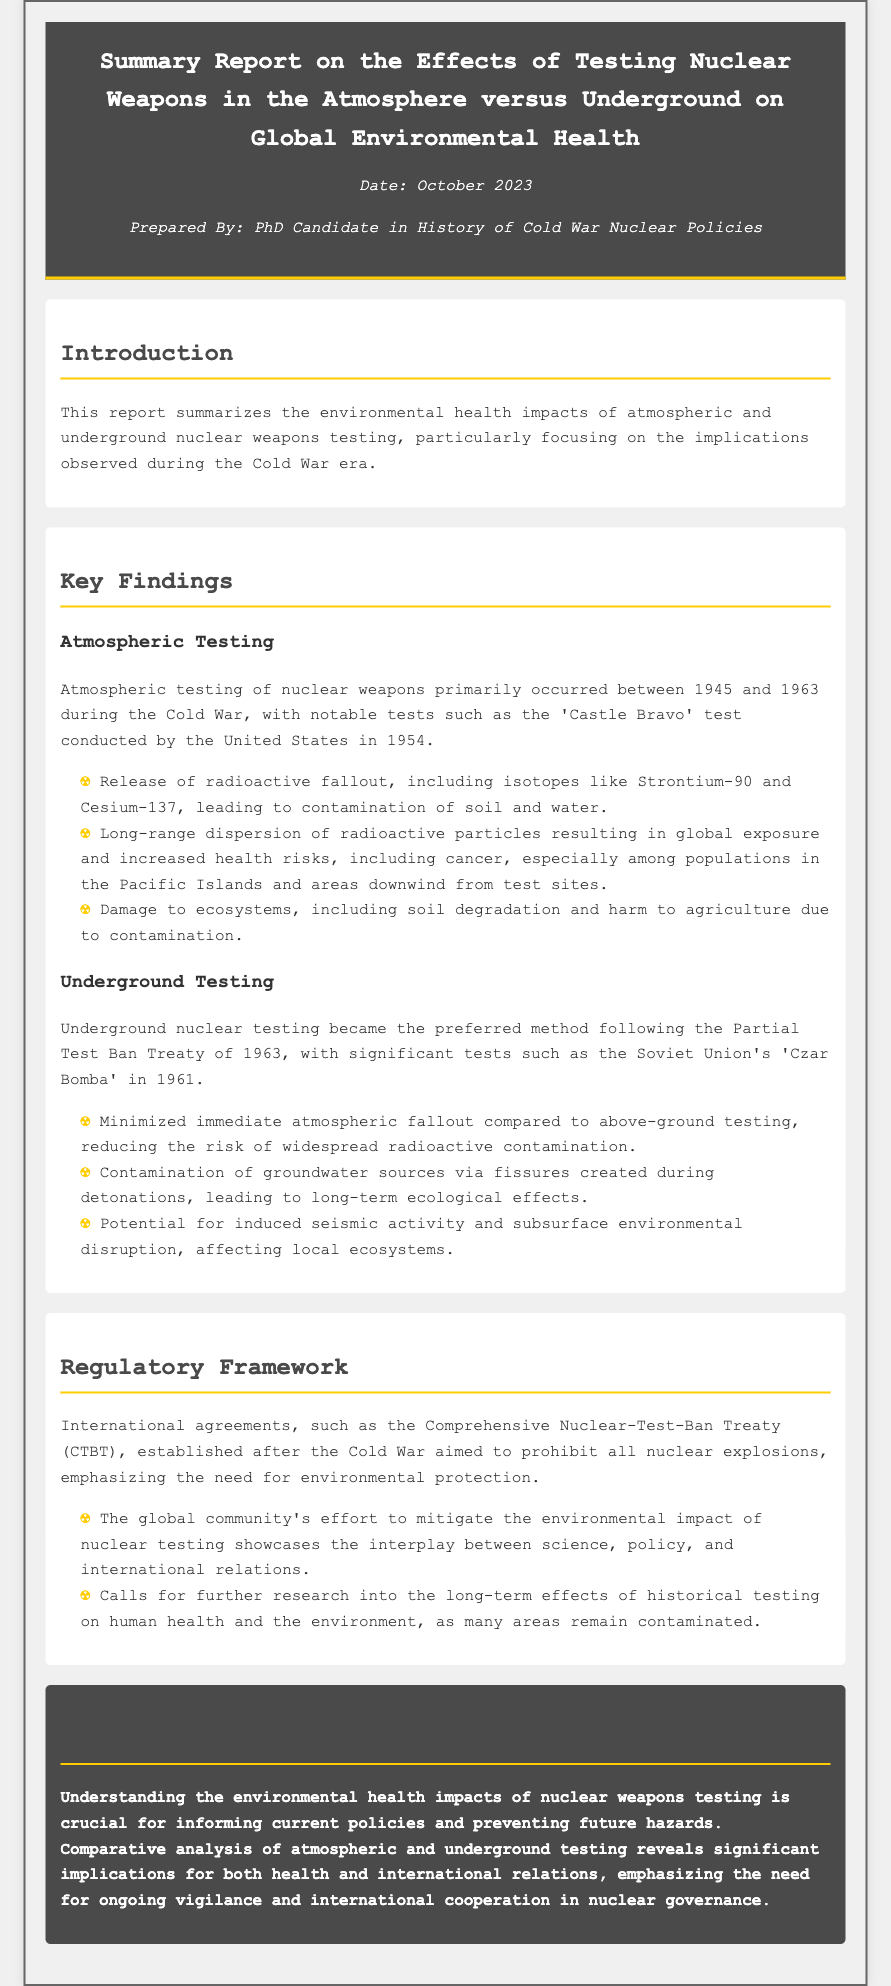What is the date of the report? The date of the report is mentioned in the meta section as October 2023.
Answer: October 2023 Who prepared the report? The report is prepared by a PhD candidate in the History of Cold War Nuclear Policies, as stated in the meta section.
Answer: PhD Candidate in History of Cold War Nuclear Policies What was a significant atmospheric test mentioned? The significant atmospheric test mentioned is the 'Castle Bravo' test conducted by the United States in 1954.
Answer: Castle Bravo What isotopes were released due to atmospheric testing? The isotopes released due to atmospheric testing include Strontium-90 and Cesium-137, as listed in the findings section.
Answer: Strontium-90 and Cesium-137 What is one long-term effect of underground testing? One long-term effect of underground testing is the contamination of groundwater sources via fissures created during detonations.
Answer: Contamination of groundwater sources What treaty aimed to prohibit all nuclear explosions? The treaty that aimed to prohibit all nuclear explosions is the Comprehensive Nuclear-Test-Ban Treaty (CTBT) as stated in the regulatory framework section.
Answer: Comprehensive Nuclear-Test-Ban Treaty (CTBT) What does the report emphasize about international relations? The report emphasizes the need for ongoing vigilance and international cooperation in nuclear governance as reflected in the conclusion.
Answer: Ongoing vigilance and international cooperation What was the primary focus of the report? The primary focus of the report is on the environmental health impacts of atmospheric and underground nuclear weapons testing during the Cold War era.
Answer: Environmental health impacts What is a key finding regarding atmospheric testing? A key finding regarding atmospheric testing is the release of radioactive fallout leading to contamination of soil and water.
Answer: Release of radioactive fallout 